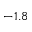<formula> <loc_0><loc_0><loc_500><loc_500>- 1 . 8</formula> 